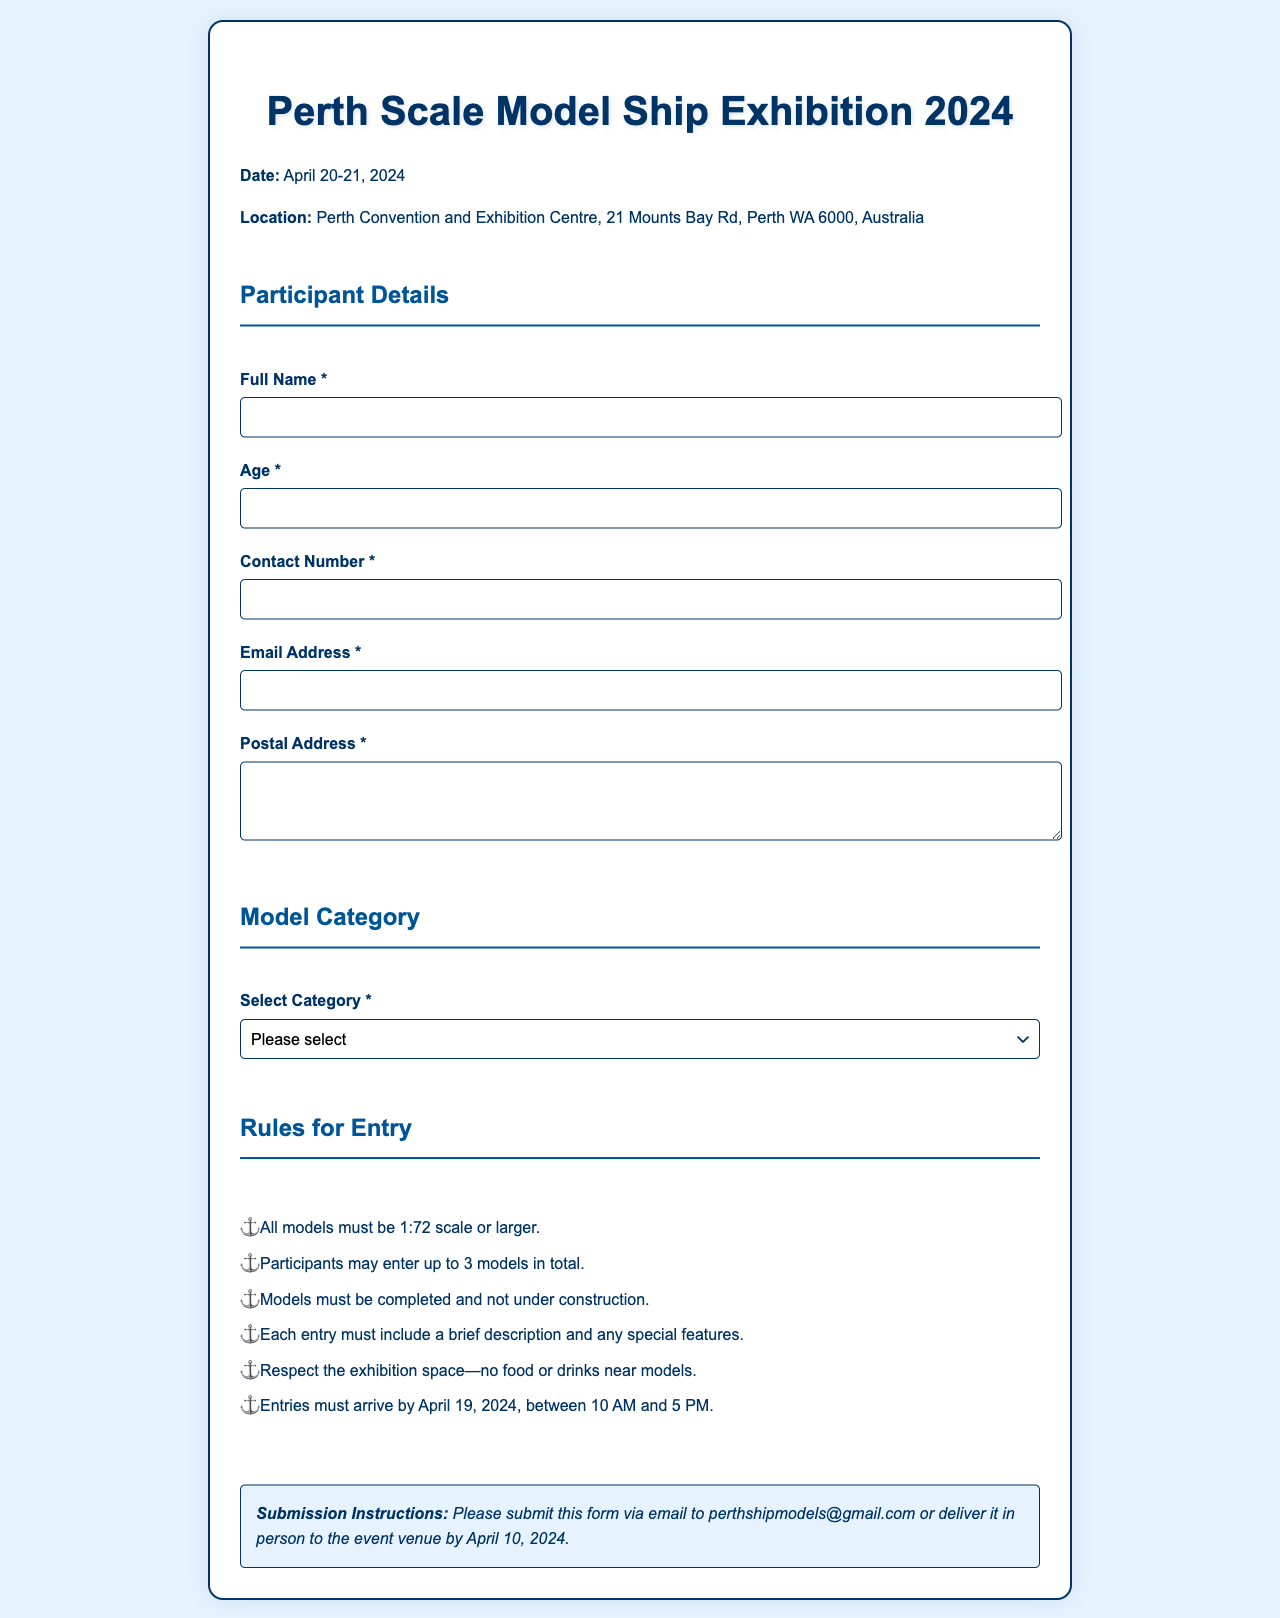what is the date of the exhibition? The exhibition is scheduled for April 20-21, 2024.
Answer: April 20-21, 2024 where is the exhibition located? The exhibition will be held at Perth Convention and Exhibition Centre.
Answer: Perth Convention and Exhibition Centre how many models can a participant enter? Participants are allowed to enter up to 3 models in total.
Answer: 3 models what scale must the models be? All models must be 1:72 scale or larger.
Answer: 1:72 scale or larger what is the last date for entries to arrive? Entries must arrive by April 19, 2024.
Answer: April 19, 2024 what email address should the registration form be sent to? The registration form should be sent to perthshipmodels@gmail.com.
Answer: perthshipmodels@gmail.com what should each entry include? Each entry must include a brief description and any special features.
Answer: a brief description and any special features how many categories can participants choose from? There are five categories for participants to select from.
Answer: five categories what instructions are provided for submission? Participants should submit the form via email or deliver it in person by April 10, 2024.
Answer: submit via email or deliver in person by April 10, 2024 